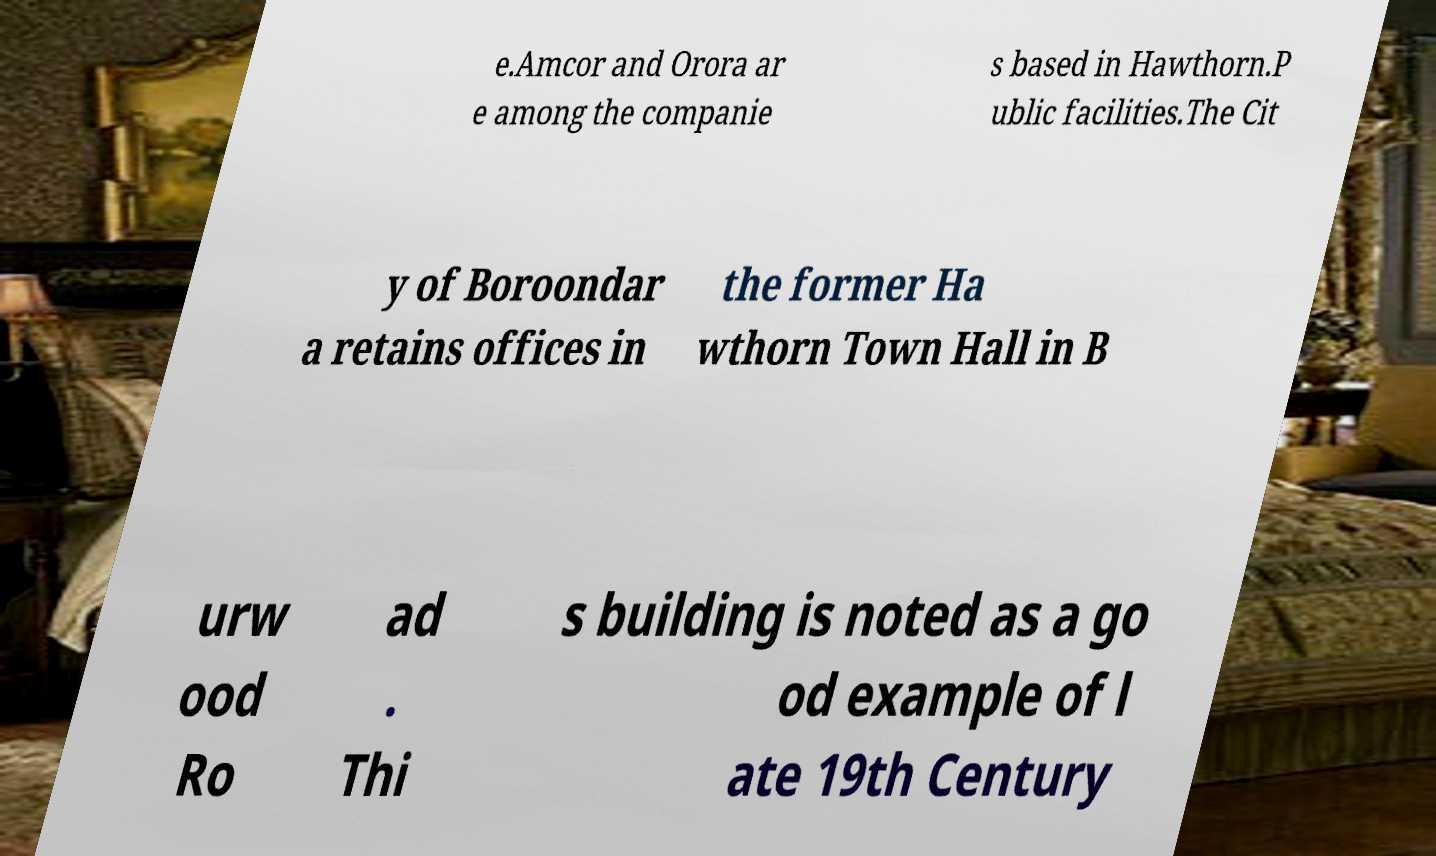There's text embedded in this image that I need extracted. Can you transcribe it verbatim? e.Amcor and Orora ar e among the companie s based in Hawthorn.P ublic facilities.The Cit y of Boroondar a retains offices in the former Ha wthorn Town Hall in B urw ood Ro ad . Thi s building is noted as a go od example of l ate 19th Century 